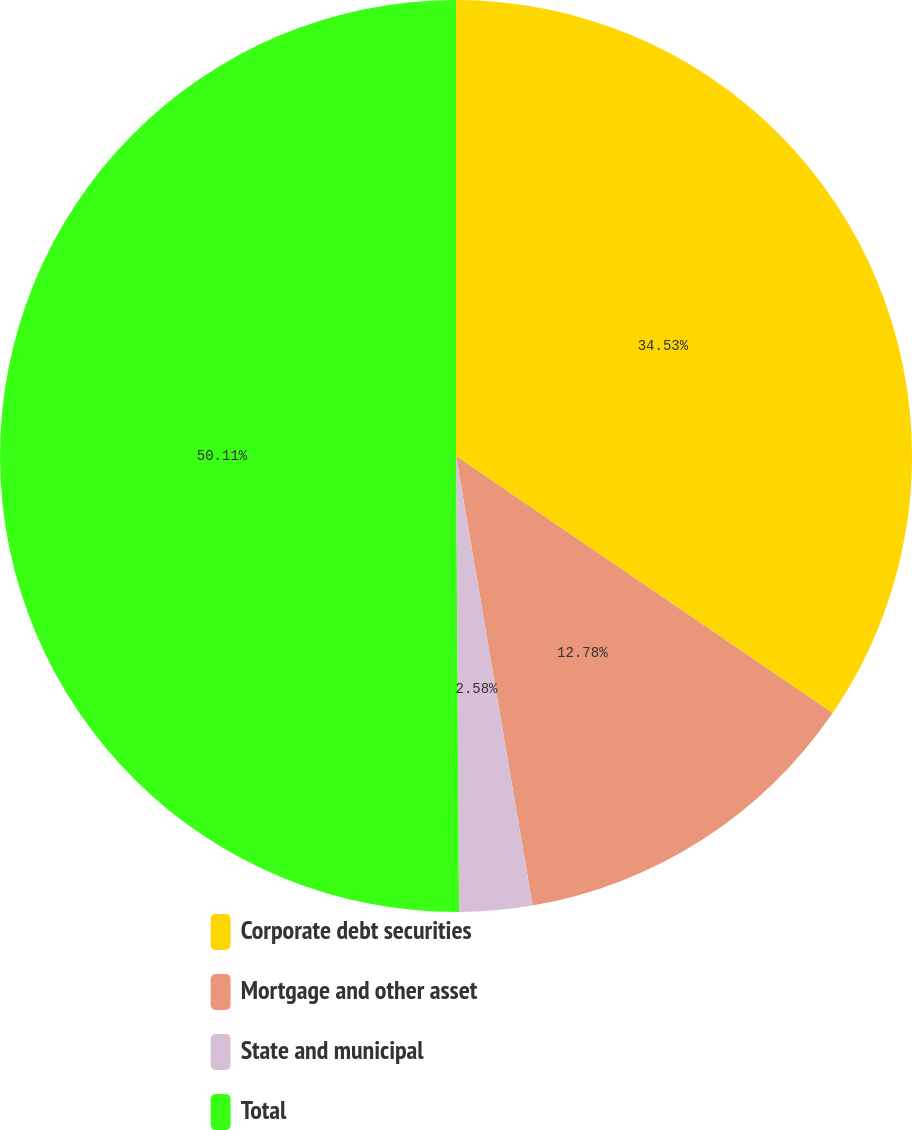Convert chart to OTSL. <chart><loc_0><loc_0><loc_500><loc_500><pie_chart><fcel>Corporate debt securities<fcel>Mortgage and other asset<fcel>State and municipal<fcel>Total<nl><fcel>34.53%<fcel>12.78%<fcel>2.58%<fcel>50.1%<nl></chart> 